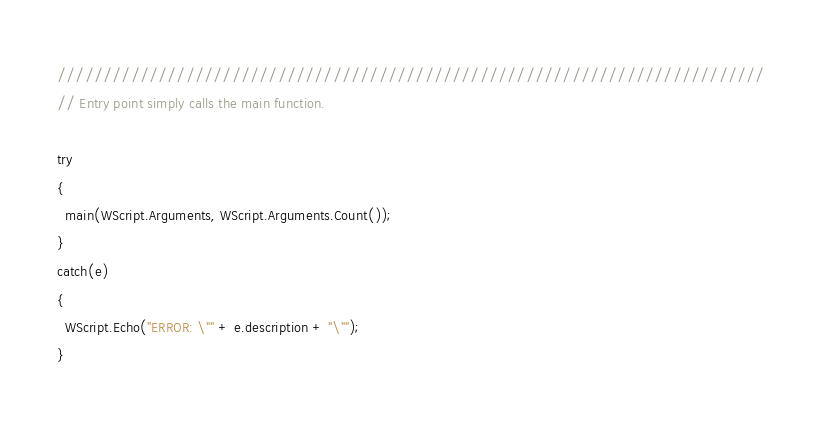<code> <loc_0><loc_0><loc_500><loc_500><_JavaScript_>/////////////////////////////////////////////////////////////////////////////
// Entry point simply calls the main function.

try
{
  main(WScript.Arguments, WScript.Arguments.Count());
}
catch(e)
{
  WScript.Echo("ERROR: \"" + e.description + "\"");
}</code> 